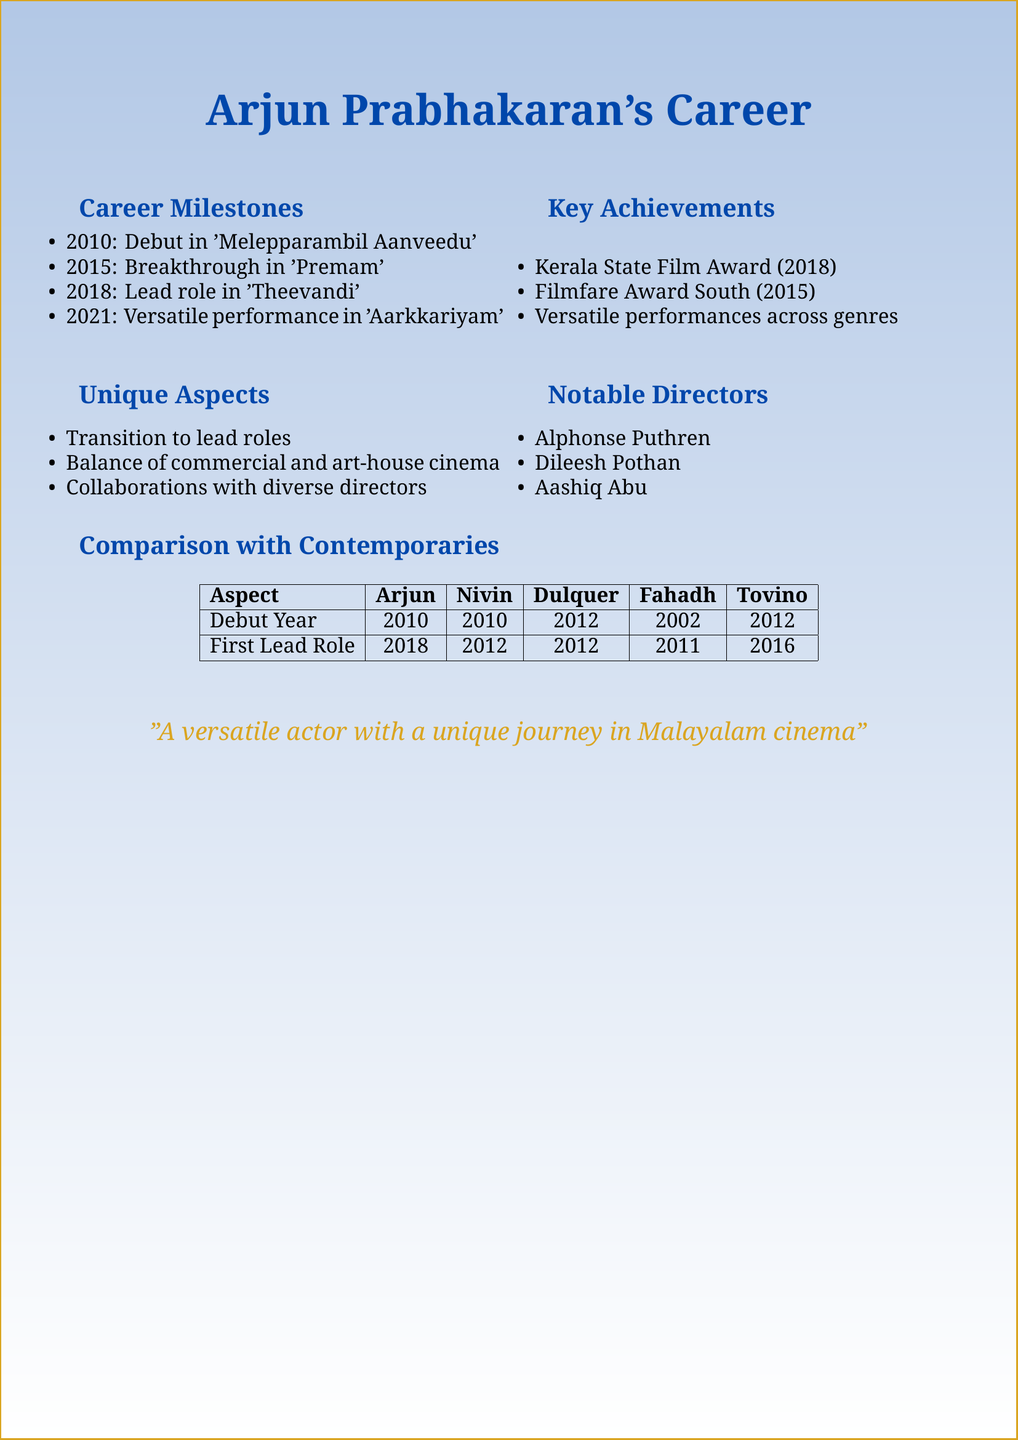What year did Arjun Prabhakaran make his debut? The debut year mentioned in the document is 2010.
Answer: 2010 Which film marked Arjun's breakthrough role? The document states that the breakthrough role was in the film 'Premam'.
Answer: Premam What award did Arjun win in 2018? According to the document, he won the Kerala State Film Award for Best Character Actor in 2018.
Answer: Kerala State Film Award for Best Character Actor Name one notable director Arjun Prabhakaran has worked with. The document lists Alphonse Puthren as one of the notable directors.
Answer: Alphonse Puthren How many years after his debut did Arjun get his first lead role? The document mentions that his debut was in 2010 and he got his first lead role in 2018, which is 8 years later.
Answer: 8 years Which actor debuted earlier in the Malayalam film industry, Arjun Prabhakaran or Fahadh Faasil? The document shows that Fahadh Faasil debuted in 2002, earlier than Arjun's debut in 2010.
Answer: Fahadh Faasil What unique aspect of Arjun's career is highlighted in the document? The document highlights his transition from supporting roles to lead actor as a unique aspect.
Answer: Transition from supporting roles to lead actor How many contemporary actors are compared to Arjun in the document? The document lists four contemporary actors compared to Arjun Prabhakaran.
Answer: Four 